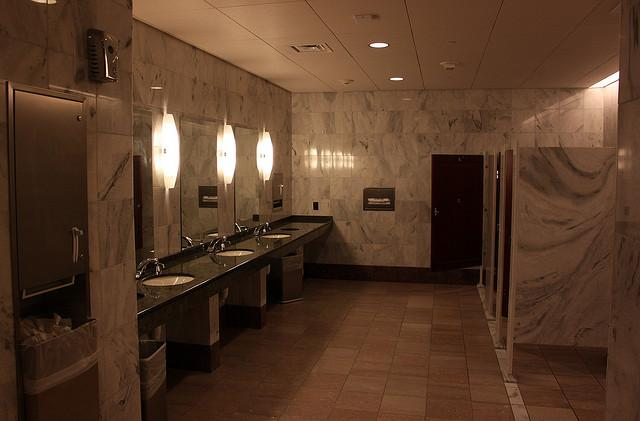Where might this bathroom be?

Choices:
A) school
B) casino
C) library
D) house casino 